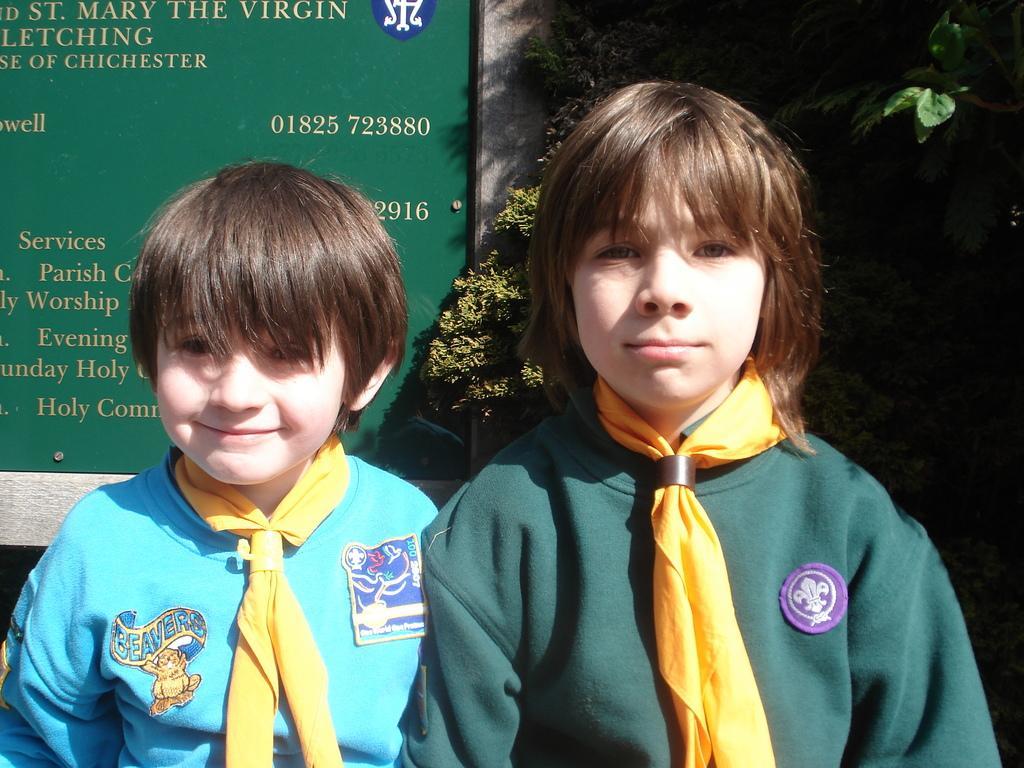Could you give a brief overview of what you see in this image? In this image I can see a child wearing blue and yellow colored dress and another child wearing green and yellow colored dress. In the background I can see few trees and a huge green colored board. 